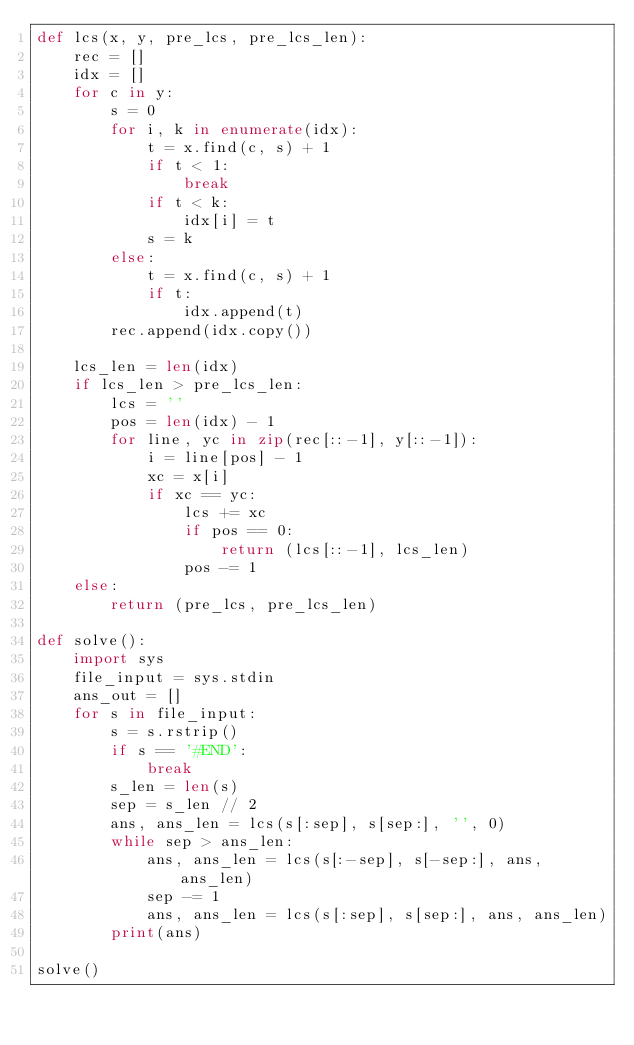Convert code to text. <code><loc_0><loc_0><loc_500><loc_500><_Python_>def lcs(x, y, pre_lcs, pre_lcs_len):
    rec = []
    idx = []
    for c in y:
        s = 0
        for i, k in enumerate(idx):
            t = x.find(c, s) + 1
            if t < 1:
                break
            if t < k:
                idx[i] = t
            s = k
        else:
            t = x.find(c, s) + 1
            if t:
                idx.append(t)
        rec.append(idx.copy())
    
    lcs_len = len(idx)
    if lcs_len > pre_lcs_len:
        lcs = ''
        pos = len(idx) - 1
        for line, yc in zip(rec[::-1], y[::-1]):
            i = line[pos] - 1
            xc = x[i]
            if xc == yc:
                lcs += xc
                if pos == 0:
                    return (lcs[::-1], lcs_len)
                pos -= 1
    else:
        return (pre_lcs, pre_lcs_len)

def solve():
    import sys
    file_input = sys.stdin
    ans_out = []
    for s in file_input:
        s = s.rstrip()
        if s == '#END':
            break
        s_len = len(s)
        sep = s_len // 2
        ans, ans_len = lcs(s[:sep], s[sep:], '', 0)
        while sep > ans_len:
            ans, ans_len = lcs(s[:-sep], s[-sep:], ans, ans_len)
            sep -= 1
            ans, ans_len = lcs(s[:sep], s[sep:], ans, ans_len)
        print(ans)

solve()
</code> 